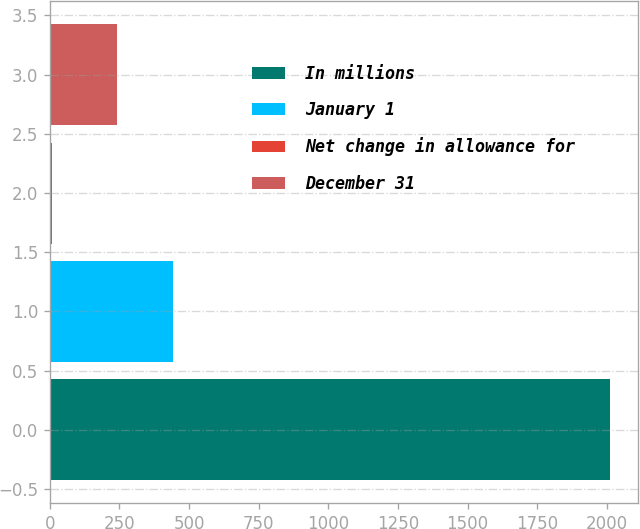Convert chart to OTSL. <chart><loc_0><loc_0><loc_500><loc_500><bar_chart><fcel>In millions<fcel>January 1<fcel>Net change in allowance for<fcel>December 31<nl><fcel>2013<fcel>442.5<fcel>8<fcel>242<nl></chart> 